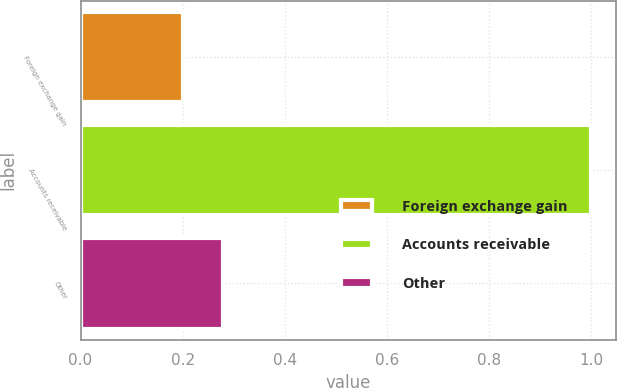<chart> <loc_0><loc_0><loc_500><loc_500><bar_chart><fcel>Foreign exchange gain<fcel>Accounts receivable<fcel>Other<nl><fcel>0.2<fcel>1<fcel>0.28<nl></chart> 